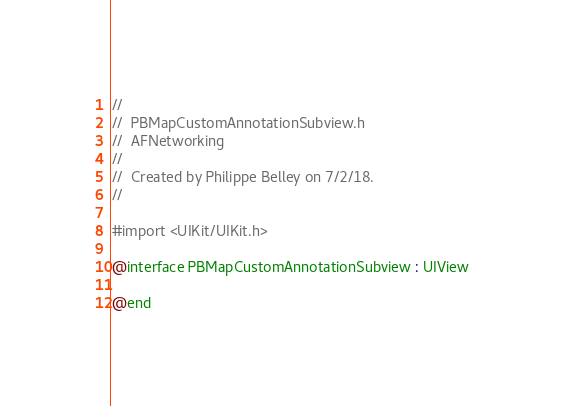Convert code to text. <code><loc_0><loc_0><loc_500><loc_500><_C_>//
//  PBMapCustomAnnotationSubview.h
//  AFNetworking
//
//  Created by Philippe Belley on 7/2/18.
//

#import <UIKit/UIKit.h>

@interface PBMapCustomAnnotationSubview : UIView

@end
</code> 